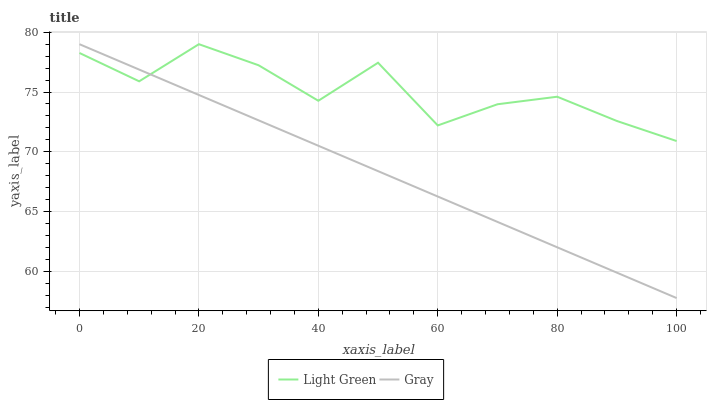Does Gray have the minimum area under the curve?
Answer yes or no. Yes. Does Light Green have the maximum area under the curve?
Answer yes or no. Yes. Does Light Green have the minimum area under the curve?
Answer yes or no. No. Is Gray the smoothest?
Answer yes or no. Yes. Is Light Green the roughest?
Answer yes or no. Yes. Is Light Green the smoothest?
Answer yes or no. No. Does Gray have the lowest value?
Answer yes or no. Yes. Does Light Green have the lowest value?
Answer yes or no. No. Does Light Green have the highest value?
Answer yes or no. Yes. Does Gray intersect Light Green?
Answer yes or no. Yes. Is Gray less than Light Green?
Answer yes or no. No. Is Gray greater than Light Green?
Answer yes or no. No. 